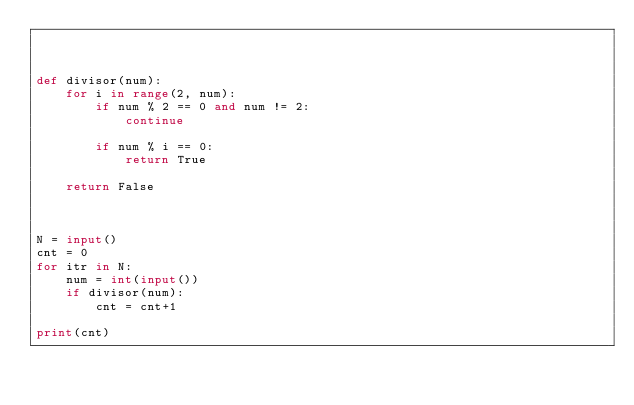<code> <loc_0><loc_0><loc_500><loc_500><_Python_>


def divisor(num):
    for i in range(2, num):
        if num % 2 == 0 and num != 2:
            continue

        if num % i == 0:
            return True

    return False



N = input()
cnt = 0
for itr in N:
    num = int(input())
    if divisor(num):
        cnt = cnt+1

print(cnt)
</code> 